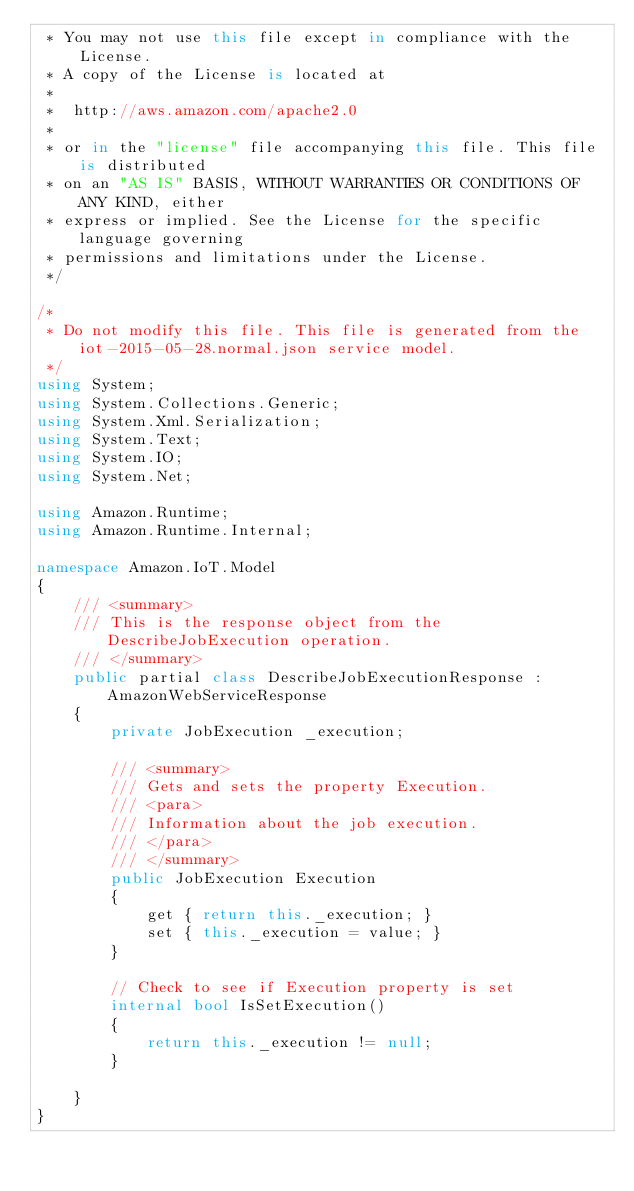<code> <loc_0><loc_0><loc_500><loc_500><_C#_> * You may not use this file except in compliance with the License.
 * A copy of the License is located at
 * 
 *  http://aws.amazon.com/apache2.0
 * 
 * or in the "license" file accompanying this file. This file is distributed
 * on an "AS IS" BASIS, WITHOUT WARRANTIES OR CONDITIONS OF ANY KIND, either
 * express or implied. See the License for the specific language governing
 * permissions and limitations under the License.
 */

/*
 * Do not modify this file. This file is generated from the iot-2015-05-28.normal.json service model.
 */
using System;
using System.Collections.Generic;
using System.Xml.Serialization;
using System.Text;
using System.IO;
using System.Net;

using Amazon.Runtime;
using Amazon.Runtime.Internal;

namespace Amazon.IoT.Model
{
    /// <summary>
    /// This is the response object from the DescribeJobExecution operation.
    /// </summary>
    public partial class DescribeJobExecutionResponse : AmazonWebServiceResponse
    {
        private JobExecution _execution;

        /// <summary>
        /// Gets and sets the property Execution. 
        /// <para>
        /// Information about the job execution.
        /// </para>
        /// </summary>
        public JobExecution Execution
        {
            get { return this._execution; }
            set { this._execution = value; }
        }

        // Check to see if Execution property is set
        internal bool IsSetExecution()
        {
            return this._execution != null;
        }

    }
}</code> 